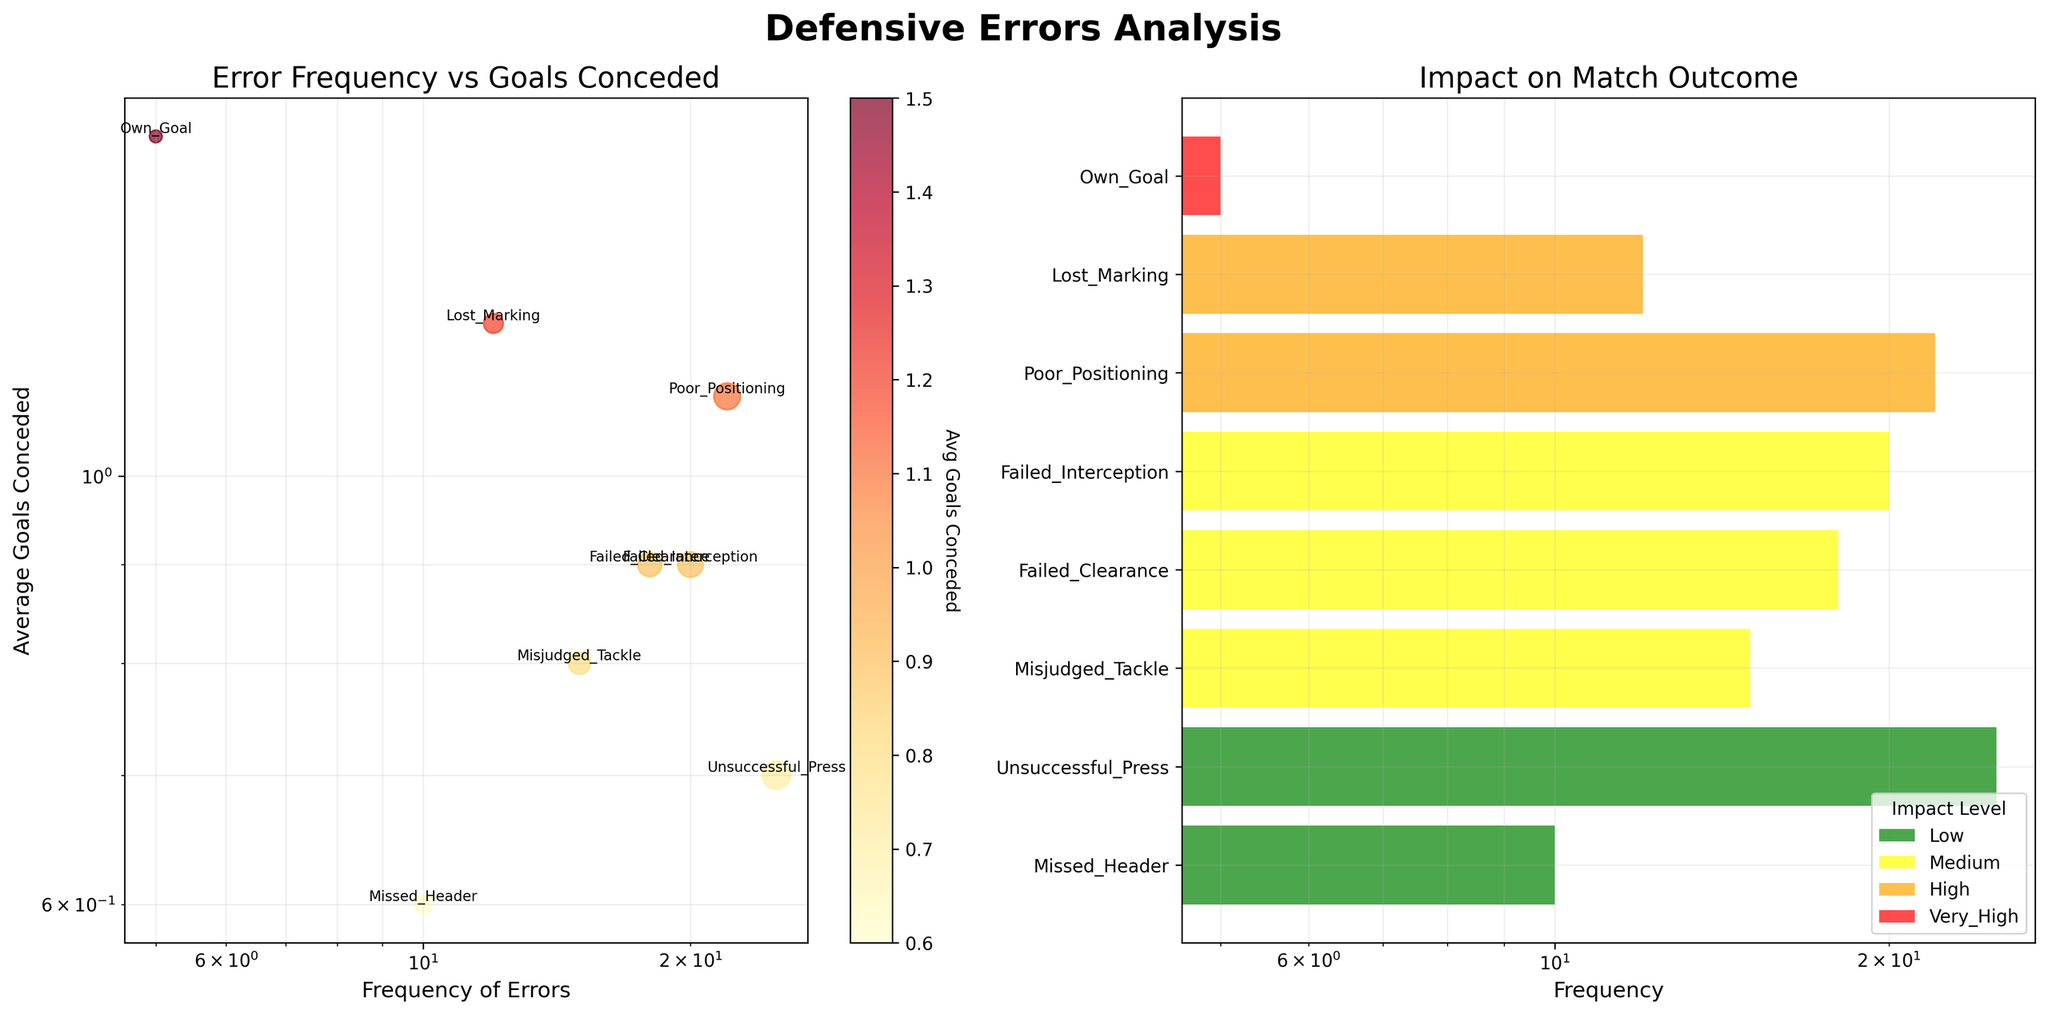What's the title of the overall figure? The overall title is located at the top and reads "Defensive Errors Analysis"
Answer: Defensive Errors Analysis What is the scale used for both x-axis and y-axis in the first subplot? In the first subplot, both the x-axis and y-axis use a logarithmic scale, indicated by the labels on the axes and the spacing of the ticks.
Answer: Logarithmic Which error type has the highest frequency and what is its impact level on match outcomes? From the bar chart, the error type with the highest frequency is "Unsuccessful Press" with a frequency of 25, and its impact on match outcome is "Low" as indicated by its green color.
Answer: Unsuccessful Press, Low Which error type has the highest average goals conceded and what is its frequency? "Own Goal" has the highest average goals conceded at 1.5, and its frequency is 5 as annotated next to the point in the scatter plot.
Answer: Own Goal, 5 How many errors have a "Medium" impact on match outcomes, and what are their total frequencies combined? There are three errors with a "Medium" impact: "Misjudged Tackle" (15), "Failed Clearance" (18), and "Failed Interception" (20). Their combined frequency is 15 + 18 + 20 = 53.
Answer: 3 errors, 53 What is the color representing the error type with the lowest average goals conceded, and what is its average goals conceded? The color representing "Missed Header" is light yellow (for low impact), and its average goals conceded is 0.6 as shown in the first subplot.
Answer: Light yellow, 0.6 Which error types are in the “High” impact level, and what are their average goals conceded values? "Poor Positioning" and "Lost Marking" have a high impact level and their average goals conceded are 1.1 and 1.2 respectively, as shown in the first subplot.
Answer: Poor Positioning: 1.1, Lost Marking: 1.2 What is the average frequency of errors that have a “Very High” impact? There is only one error type with a "Very High" impact, which is "Own Goal" with a frequency of 5. The average frequency is thus 5.
Answer: 5 Which error type has the lowest frequency and how does it impact match outcomes? "Own Goal" has the lowest frequency at 5, and it has a "Very High" impact on match outcomes as shown in the bar chart.
Answer: Own Goal, Very High How does the error type “Failed Interception” impact match outcomes and what is its average goals conceded? "Failed Interception" has a "Medium" impact on match outcomes and its average goals conceded is 0.9, as annotated in the first subplot and colored in the bar chart.
Answer: Medium, 0.9 